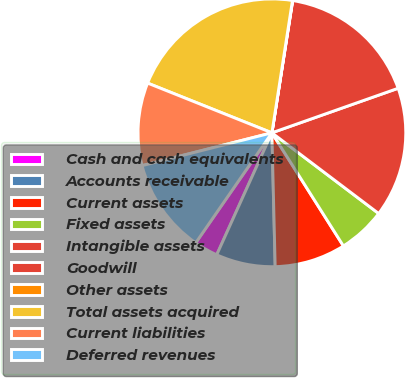Convert chart to OTSL. <chart><loc_0><loc_0><loc_500><loc_500><pie_chart><fcel>Cash and cash equivalents<fcel>Accounts receivable<fcel>Current assets<fcel>Fixed assets<fcel>Intangible assets<fcel>Goodwill<fcel>Other assets<fcel>Total assets acquired<fcel>Current liabilities<fcel>Deferred revenues<nl><fcel>2.88%<fcel>7.15%<fcel>8.58%<fcel>5.73%<fcel>15.7%<fcel>17.12%<fcel>0.03%<fcel>21.4%<fcel>10.0%<fcel>11.42%<nl></chart> 